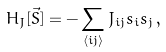<formula> <loc_0><loc_0><loc_500><loc_500>H _ { J } [ { \vec { S } } ] = - \sum _ { \langle i j \rangle } J _ { i j } s _ { i } s _ { j } \, ,</formula> 